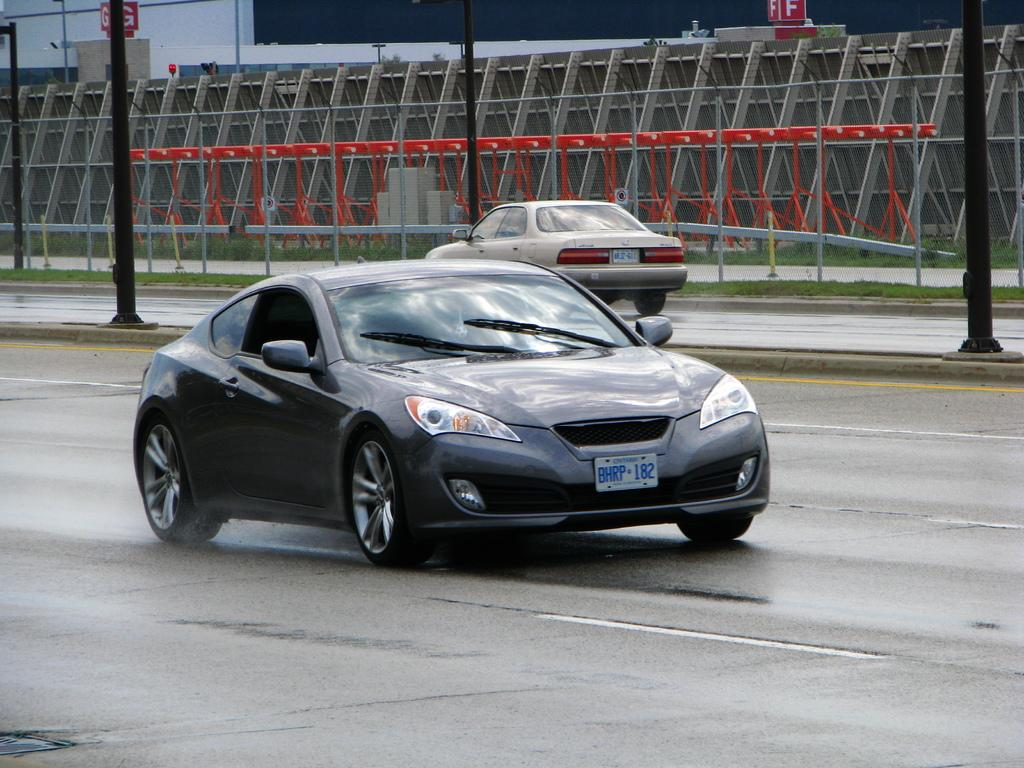How many cars can be seen on the roads in the image? There are two cars on the roads in the image. What can be seen in the background of the image? In the background, there are poles, boards, iron rods, and grass. Can you describe the poles in the background? The poles in the background are vertical structures, but their specific purpose or design cannot be determined from the image. What type of vegetation is visible in the background? Grass is visible in the background. What is your opinion on the month in which the image was taken? The image does not provide any information about the month in which it was taken, so it is not possible to form an opinion based on the image. 